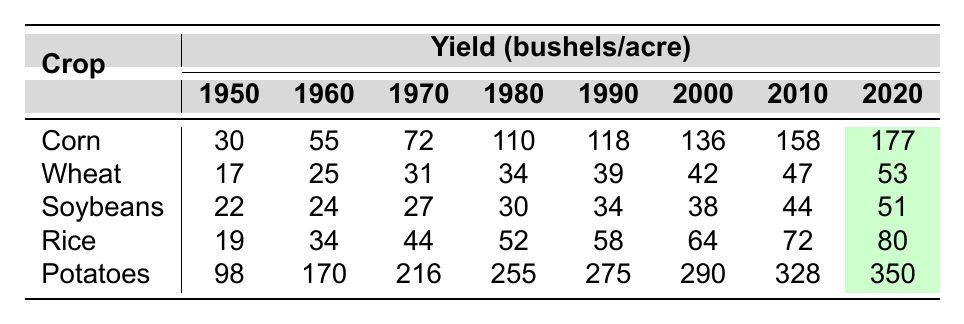What was the corn yield in 1980? The table shows the corn yield for the year 1980 as 110 bushels per acre.
Answer: 110 What was the highest yield recorded for potatoes? The highest yield for potatoes, as seen in the table, is 350 bushels per acre in the year 2020.
Answer: 350 Which crop had the lowest yield in 1950? In 1950, the crop with the lowest yield was Wheat at 17 bushels per acre.
Answer: Wheat at 17 What is the difference between the corn yields in 1950 and 2020? In 1950, the corn yield was 30 bushels per acre and in 2020 it is 177 bushels per acre. The difference is 177 - 30 = 147 bushels per acre.
Answer: 147 Which crop experienced the largest increase in yield from 1950 to 2020? To find the largest increase, calculate the difference for each crop: Corn (147), Wheat (36), Soybeans (29), Rice (61), Potatoes (252). Potatoes had the largest increase of 252 bushels per acre.
Answer: Potatoes Did soybeans yield more than rice in 2010? In 2010, soybeans had a yield of 44 bushels per acre while rice had a yield of 72 bushels per acre. Therefore, soybeans did not yield more than rice.
Answer: No What was the average yield of wheat from 1950 to 2020? The yields of wheat from 1950 to 2020 are 17, 25, 31, 34, 39, 42, 47, and 53. There are 8 data points, and the total yield is 17 + 25 + 31 + 34 + 39 + 42 + 47 + 53 = 288. The average is 288/8 = 36.
Answer: 36 In which decade did rice see its greatest increase in yield? Calculate the year-to-year yields for rice: 19 to 34 (+15), 34 to 44 (+10), 44 to 52 (+8), 52 to 58 (+6), and so on. The greatest increase was from 19 to 34 in the 1960s.
Answer: 1960s What was the yield of soybeans in 2000? The yield of soybeans in 2000 was 38 bushels per acre, as shown in the table.
Answer: 38 Is the yield of corn in 2010 greater than the yield of wheat in 2020? In 2010, corn yielded 158 bushels per acre and wheat in 2020 yielded 53 bushels per acre. Since 158 is greater than 53, the statement is true.
Answer: Yes Which crop had a yield of exactly 34 bushels per acre in 1980? The table indicates that wheat had a yield of exactly 34 bushels per acre in 1980.
Answer: Wheat 